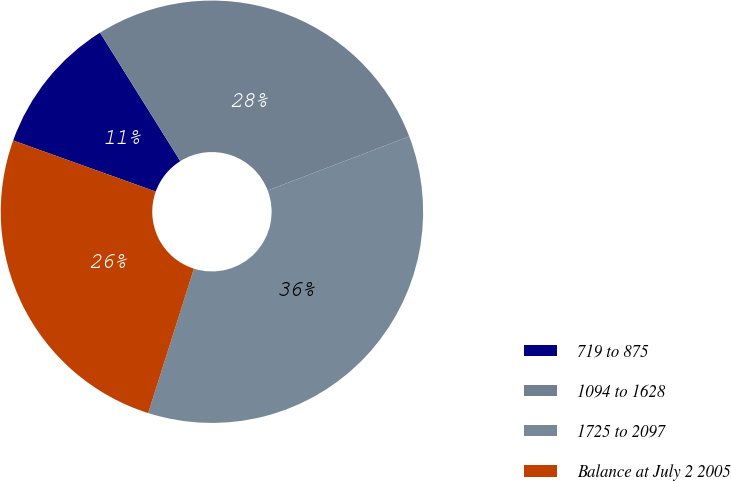Convert chart to OTSL. <chart><loc_0><loc_0><loc_500><loc_500><pie_chart><fcel>719 to 875<fcel>1094 to 1628<fcel>1725 to 2097<fcel>Balance at July 2 2005<nl><fcel>10.63%<fcel>28.09%<fcel>35.68%<fcel>25.6%<nl></chart> 